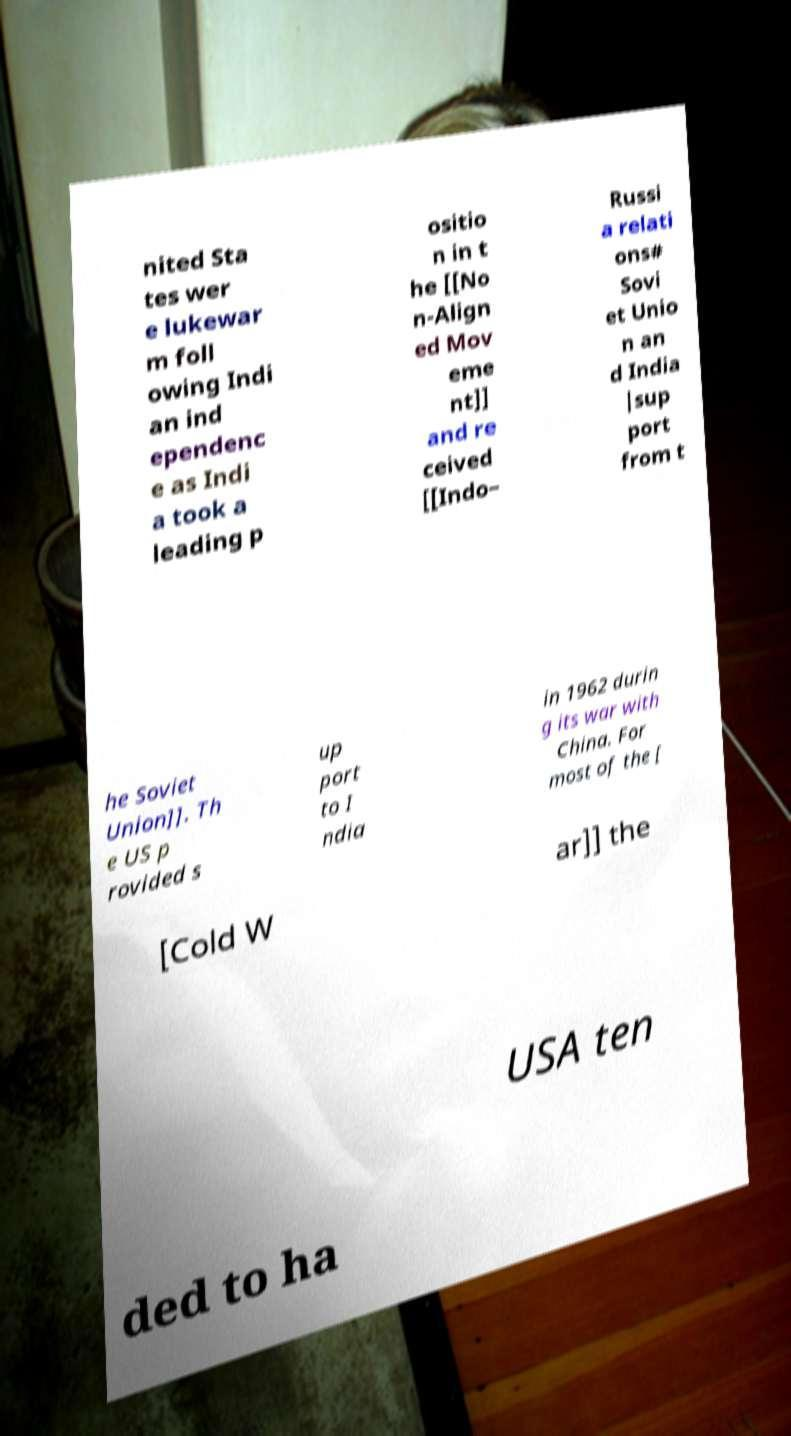Could you extract and type out the text from this image? nited Sta tes wer e lukewar m foll owing Indi an ind ependenc e as Indi a took a leading p ositio n in t he [[No n-Align ed Mov eme nt]] and re ceived [[Indo– Russi a relati ons# Sovi et Unio n an d India |sup port from t he Soviet Union]]. Th e US p rovided s up port to I ndia in 1962 durin g its war with China. For most of the [ [Cold W ar]] the USA ten ded to ha 